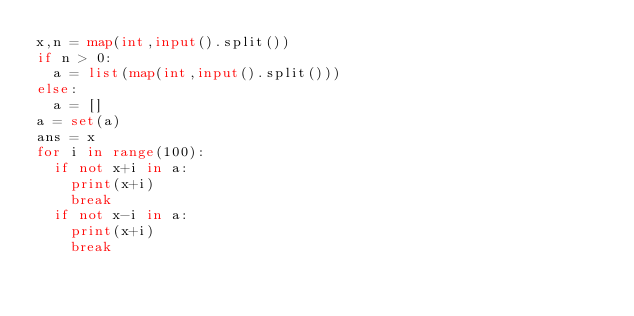Convert code to text. <code><loc_0><loc_0><loc_500><loc_500><_Python_>x,n = map(int,input().split())
if n > 0:
  a = list(map(int,input().split()))
else:
  a = []
a = set(a)
ans = x
for i in range(100):
  if not x+i in a:
    print(x+i)
    break
  if not x-i in a:
    print(x+i)
    break </code> 